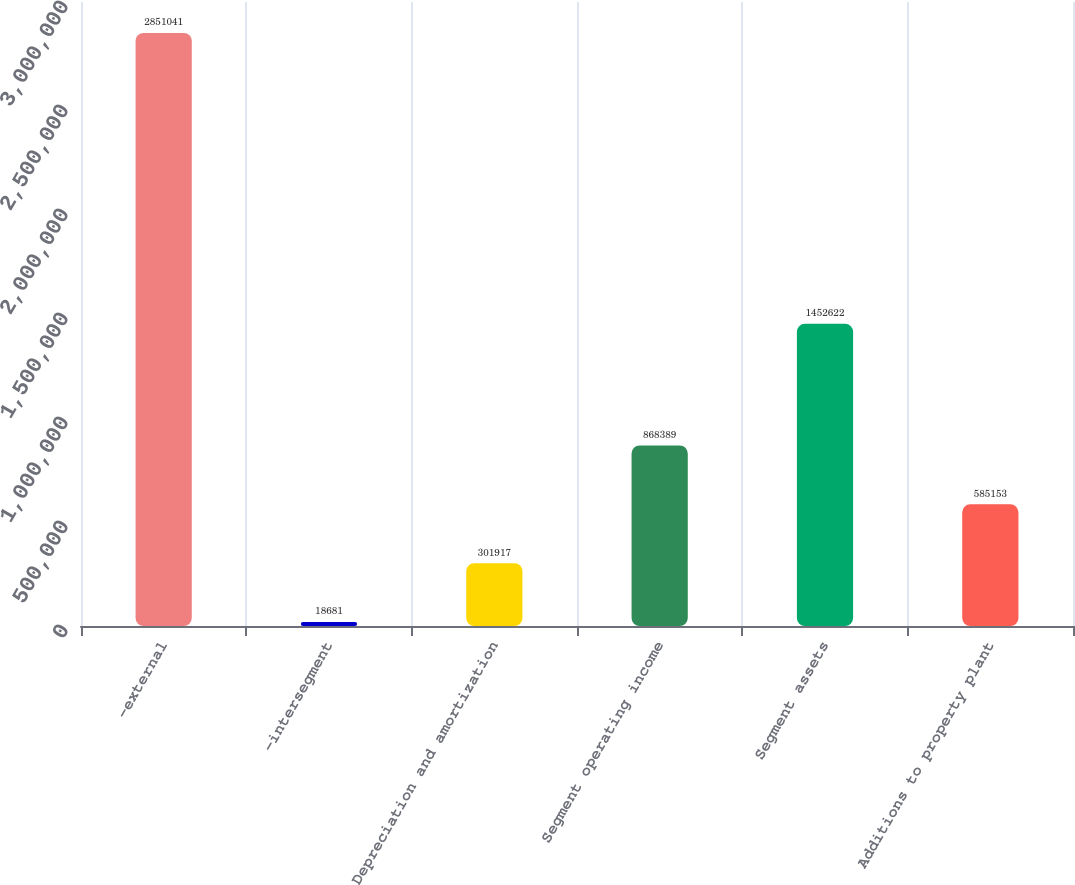Convert chart to OTSL. <chart><loc_0><loc_0><loc_500><loc_500><bar_chart><fcel>-external<fcel>-intersegment<fcel>Depreciation and amortization<fcel>Segment operating income<fcel>Segment assets<fcel>Additions to property plant<nl><fcel>2.85104e+06<fcel>18681<fcel>301917<fcel>868389<fcel>1.45262e+06<fcel>585153<nl></chart> 